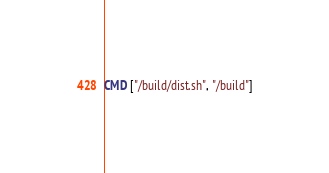Convert code to text. <code><loc_0><loc_0><loc_500><loc_500><_Dockerfile_>
CMD ["/build/dist.sh", "/build"]
</code> 